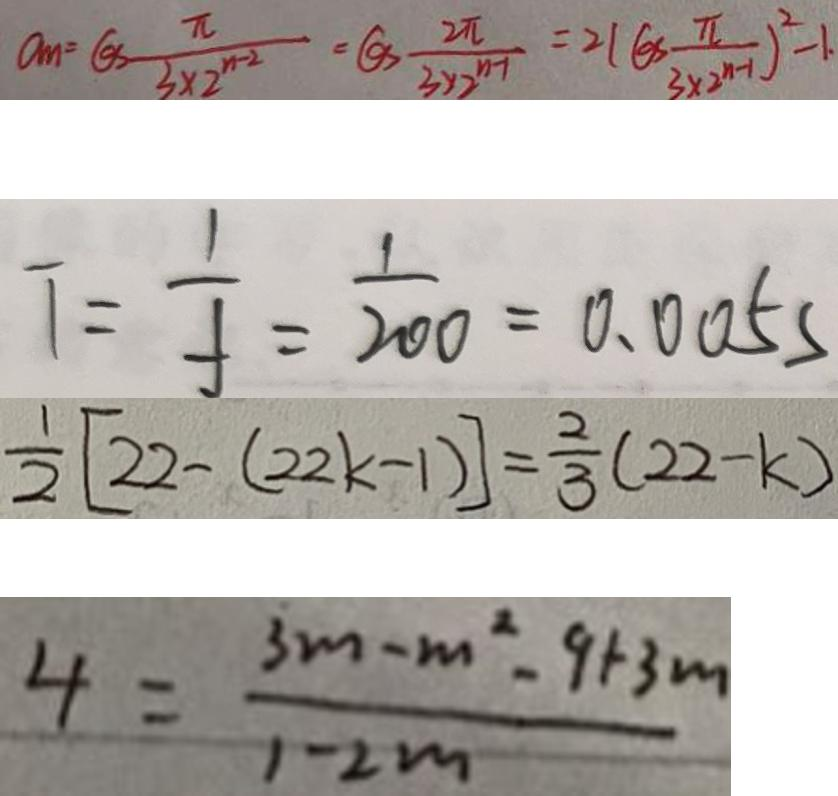Convert formula to latex. <formula><loc_0><loc_0><loc_500><loc_500>a _ { m } = G S \frac { \pi } { 3 \times 2 ^ { n - 2 } } = G S - \frac { 2 \pi } { 3 \times 2 ^ { n - 1 } } = 2 ( G S \frac { \pi } { 3 \times 2 ^ { n - 1 } } ) ^ { 2 } - 1 . 
 T = \frac { 1 } { f } = \frac { 1 } { 2 0 0 } = 0 . 0 0 5 s 
 \frac { 1 } { 2 } [ 2 2 - ( 2 2 k - 1 ) ] = \frac { 2 } { 3 } ( 2 2 - k ) 
 4 = \frac { 3 m - m ^ { 2 } - 9 + 3 m } { 1 - 2 m }</formula> 